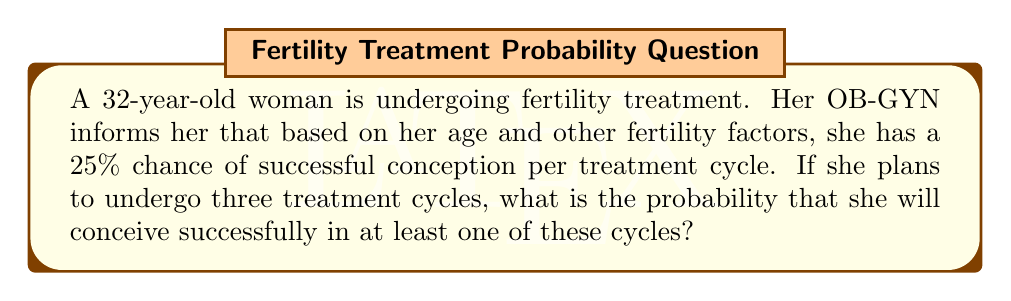What is the answer to this math problem? To solve this problem, we need to use the concept of probability for independent events.

1) First, let's calculate the probability of not conceiving in a single cycle:
   $P(\text{not conceiving}) = 1 - P(\text{conceiving}) = 1 - 0.25 = 0.75$ or 75%

2) Since the cycles are independent, the probability of not conceiving in all three cycles is:
   $P(\text{not conceiving in all 3 cycles}) = 0.75 \times 0.75 \times 0.75 = 0.75^3 = 0.421875$ or about 42.19%

3) The probability of conceiving in at least one cycle is the opposite of not conceiving in any cycle:
   $P(\text{conceiving in at least one cycle}) = 1 - P(\text{not conceiving in all 3 cycles})$
   $= 1 - 0.421875 = 0.578125$

4) Converting to a percentage:
   $0.578125 \times 100\% = 57.8125\%$

Therefore, the probability of successful conception in at least one of the three treatment cycles is approximately 57.81%.
Answer: The probability of successful conception in at least one of the three treatment cycles is approximately 57.81%. 